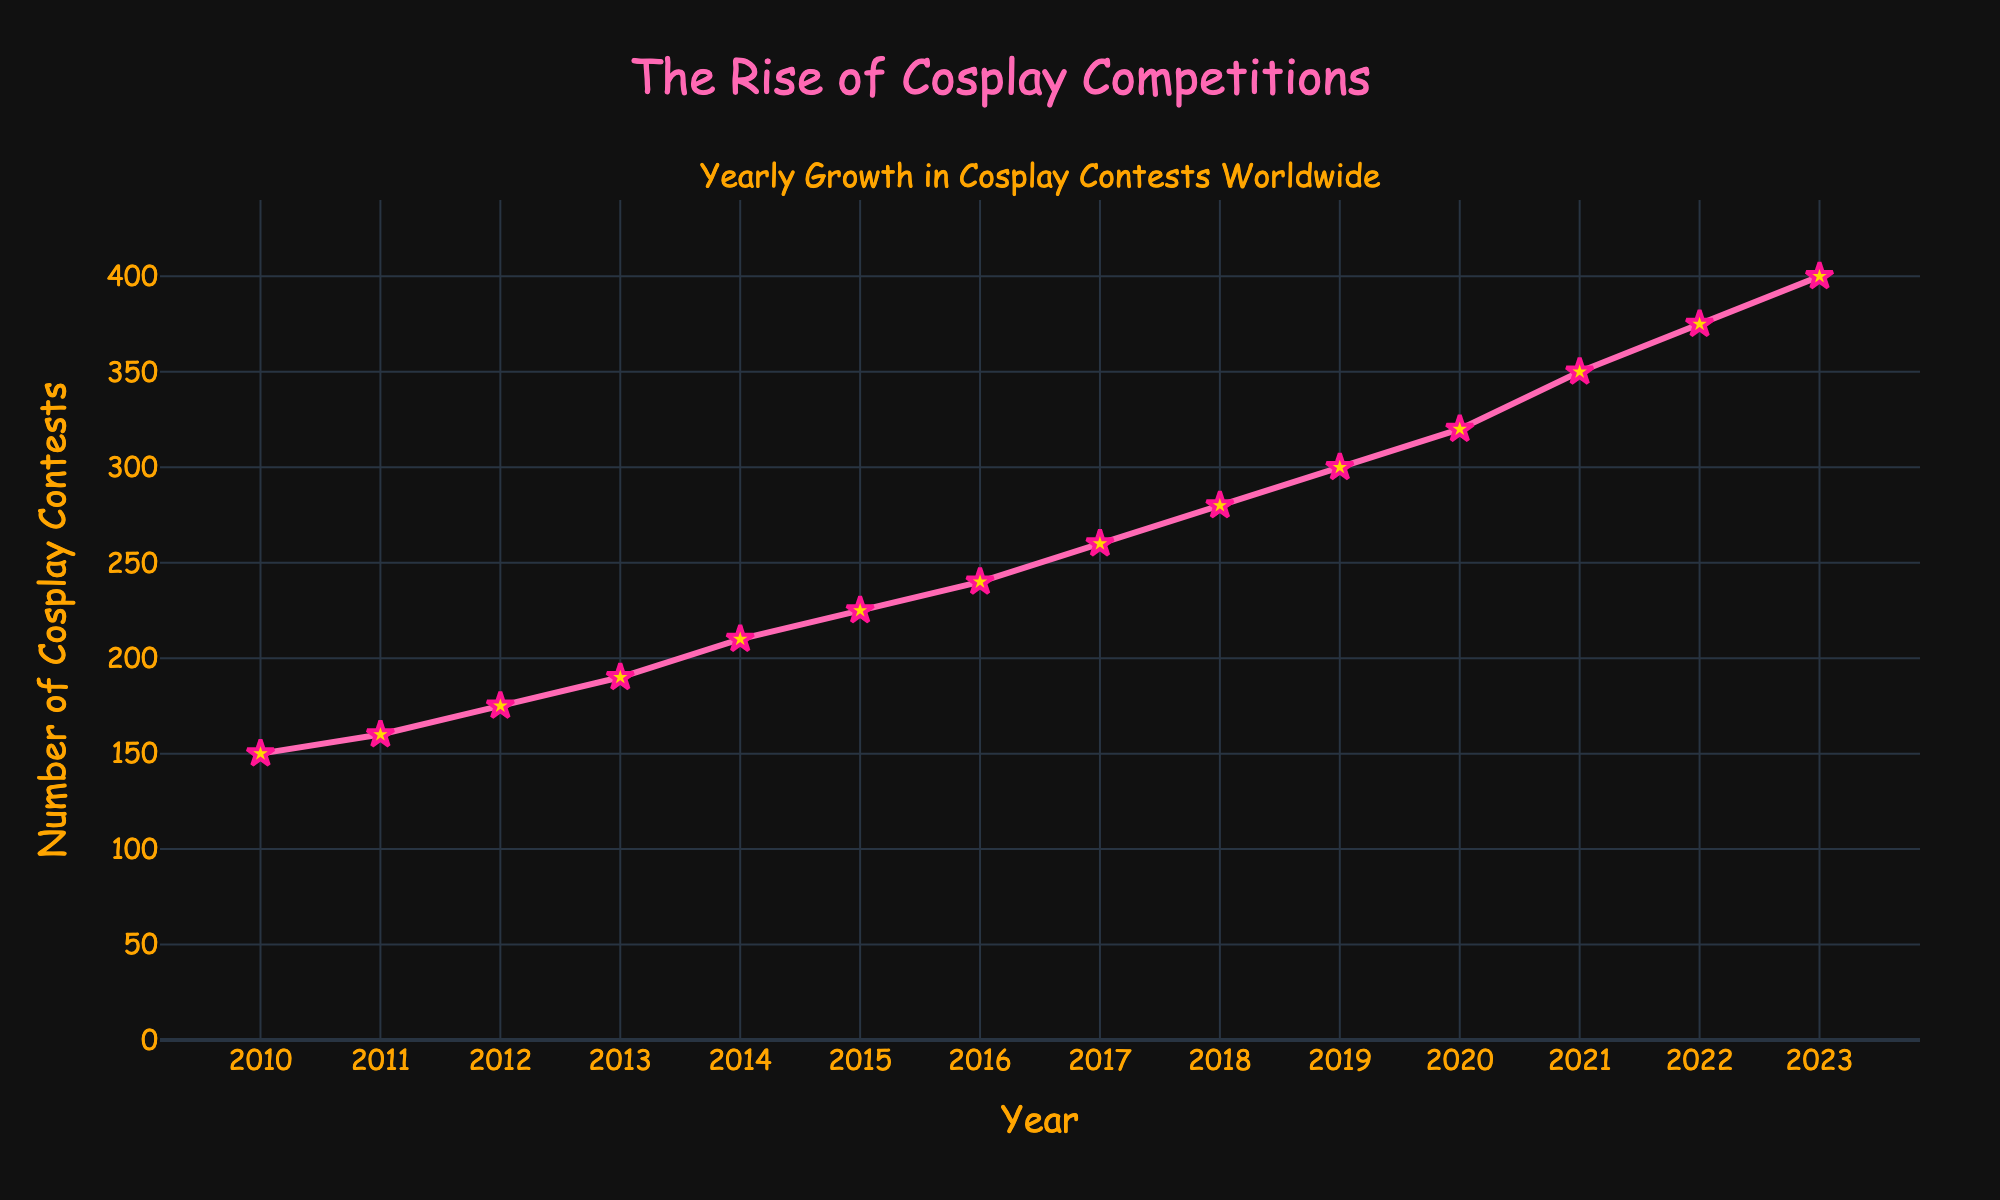What is the title of the plot? The title of the plot is displayed prominently at the top of the figure.
Answer: The Rise of Cosplay Competitions Which year had the highest number of cosplay contests? Referring to the y-axis values, the year with the highest value is the year 2023.
Answer: 2023 By how many contests did the number of cosplay contests increase from 2010 to 2023? Subtract the number of contests in 2010 from the number of contests in 2023 (400 - 150 = 250).
Answer: 250 Which year saw the largest single yearly increase in the number of cosplay contests? Examining the differences between consecutive points, the largest increase occurs between 2020 (320) and 2021 (350), which is an increase of 30 contests.
Answer: 2021 On average, how many new cosplay contests were added each year from 2010 to 2023? The total increase from 2010 to 2023 is 250 contests. There are 13 years in this period. Average increase = 250 / 13 ≈ 19.23 contests per year.
Answer: 19.23 Which years have the same color for their markers? All years have the same marker color, which is gold.
Answer: All What is the sum of the number of cosplay contests for the years 2020, 2021, and 2022? Adding the number of contests for these years: 320 (2020) + 350 (2021) + 375 (2022) = 1045.
Answer: 1045 How many years are plotted in the figure? Count the total number of data points from 2010 to 2023, inclusive.
Answer: 14 Is the trend in the number of cosplay contests increasing, decreasing, or stable over time? The line plot shows a clear upward trend in the number of contests over the years.
Answer: Increasing Describe the layout theme and font style used in the plot. The plot uses a dark theme, with a Comic Sans MS font style in orange color for the labels and title text.
Answer: Dark theme, Comic Sans MS, orange font 